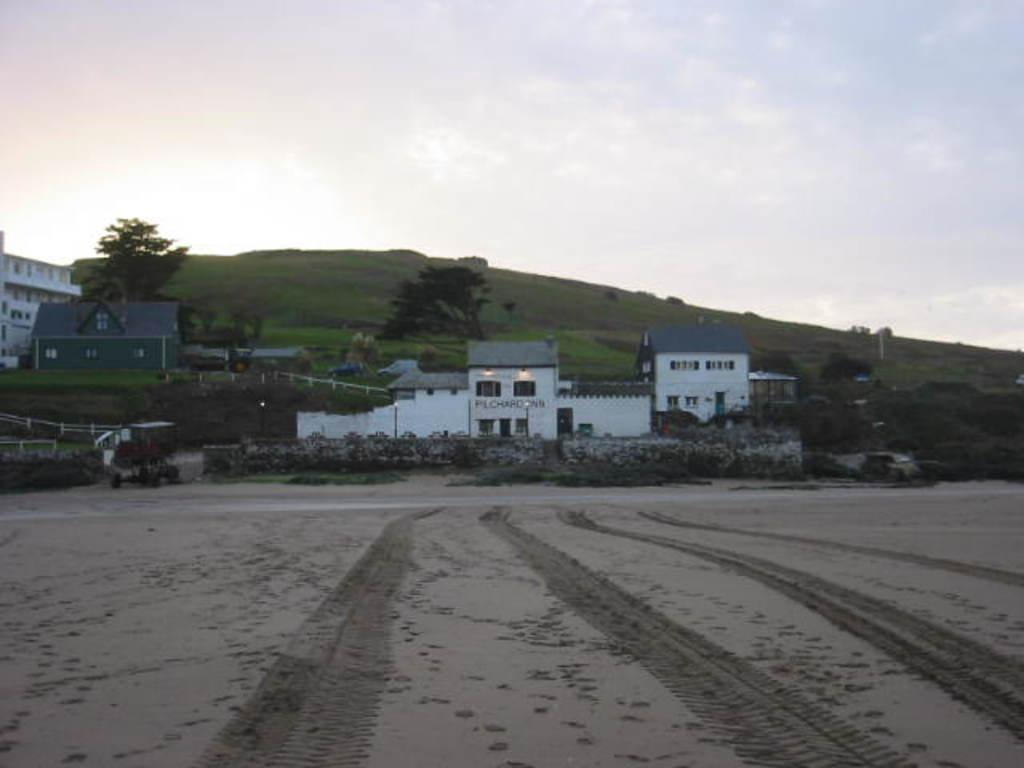What type of structures can be seen in the image? There are buildings in the image. What natural elements are present in the image? There are trees and a hill in the image. What is visible at the top of the image? The sky is visible at the top of the image. What is the governor's opinion on the profitability of the journey depicted in the image? There is no governor or journey depicted in the image, so it is not possible to answer that question. 